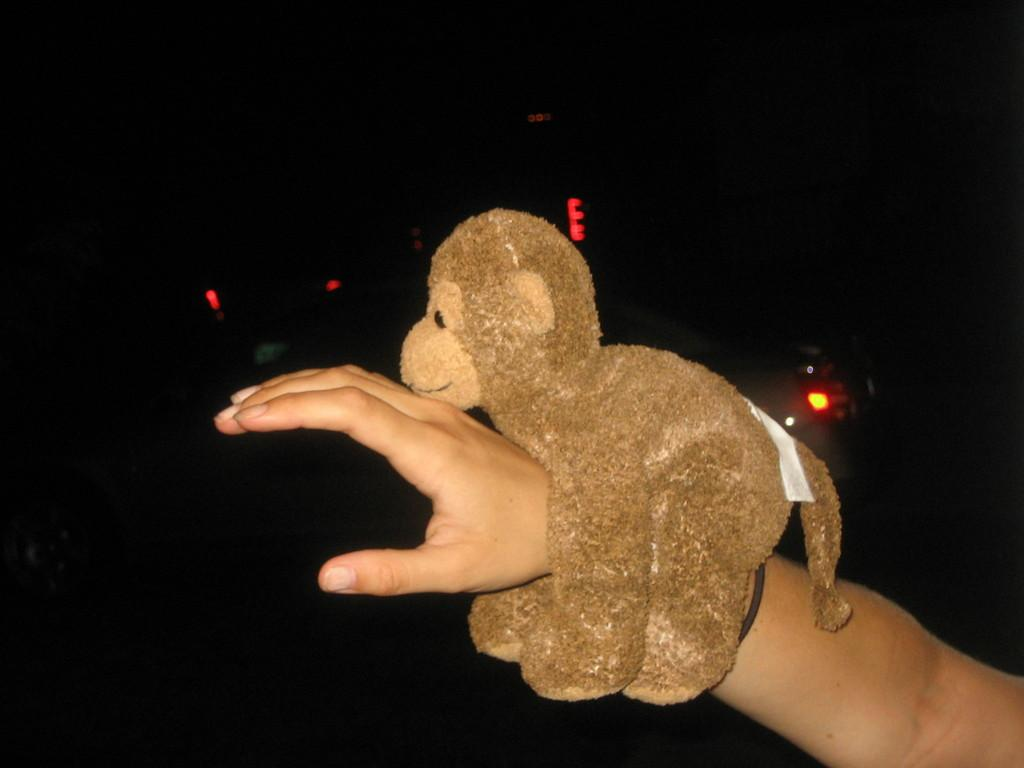What is on the person's hand in the image? A monkey toy is placed on the hand. What can be seen in the background of the image? The background of the image is dark. What is visible in the image besides the hand and the monkey toy? There are lights visible in the image. What request does the person make to the monkey toy in the image? There is no indication in the image that the person is making a request to the monkey toy. 